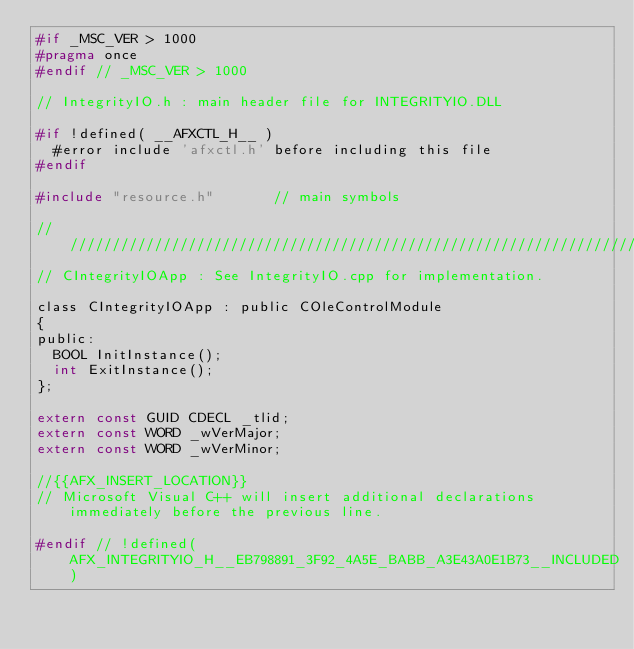Convert code to text. <code><loc_0><loc_0><loc_500><loc_500><_C_>#if _MSC_VER > 1000
#pragma once
#endif // _MSC_VER > 1000

// IntegrityIO.h : main header file for INTEGRITYIO.DLL

#if !defined( __AFXCTL_H__ )
	#error include 'afxctl.h' before including this file
#endif

#include "resource.h"       // main symbols

/////////////////////////////////////////////////////////////////////////////
// CIntegrityIOApp : See IntegrityIO.cpp for implementation.

class CIntegrityIOApp : public COleControlModule
{
public:
	BOOL InitInstance();
	int ExitInstance();
};

extern const GUID CDECL _tlid;
extern const WORD _wVerMajor;
extern const WORD _wVerMinor;

//{{AFX_INSERT_LOCATION}}
// Microsoft Visual C++ will insert additional declarations immediately before the previous line.

#endif // !defined(AFX_INTEGRITYIO_H__EB798891_3F92_4A5E_BABB_A3E43A0E1B73__INCLUDED)
</code> 